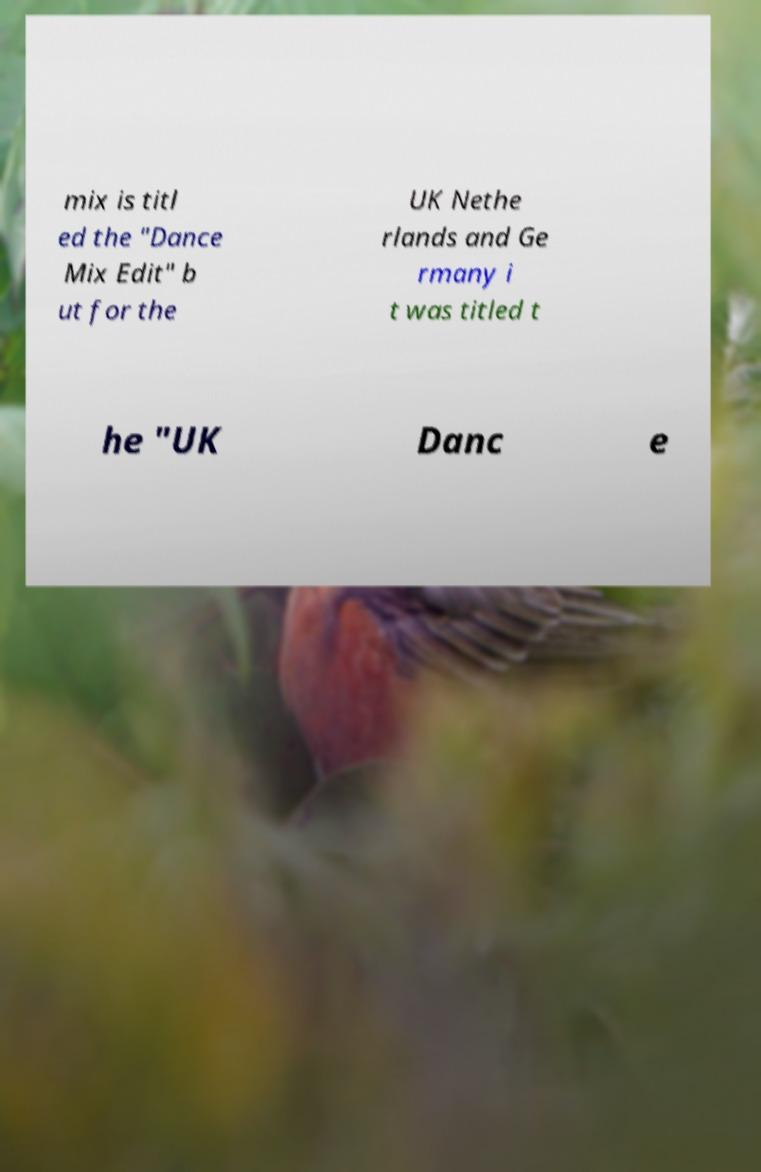I need the written content from this picture converted into text. Can you do that? mix is titl ed the "Dance Mix Edit" b ut for the UK Nethe rlands and Ge rmany i t was titled t he "UK Danc e 